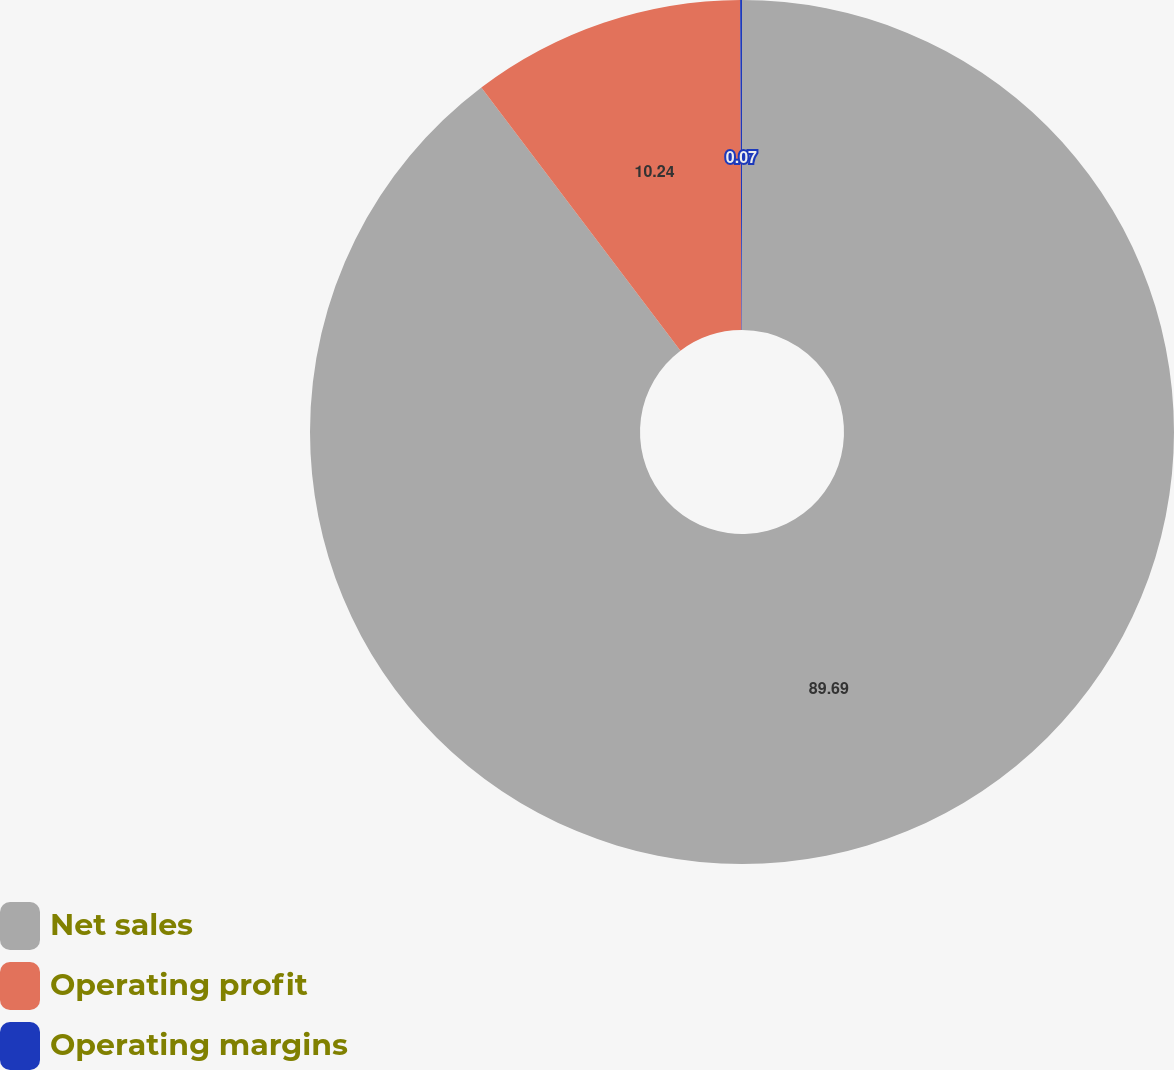Convert chart. <chart><loc_0><loc_0><loc_500><loc_500><pie_chart><fcel>Net sales<fcel>Operating profit<fcel>Operating margins<nl><fcel>89.69%<fcel>10.24%<fcel>0.07%<nl></chart> 